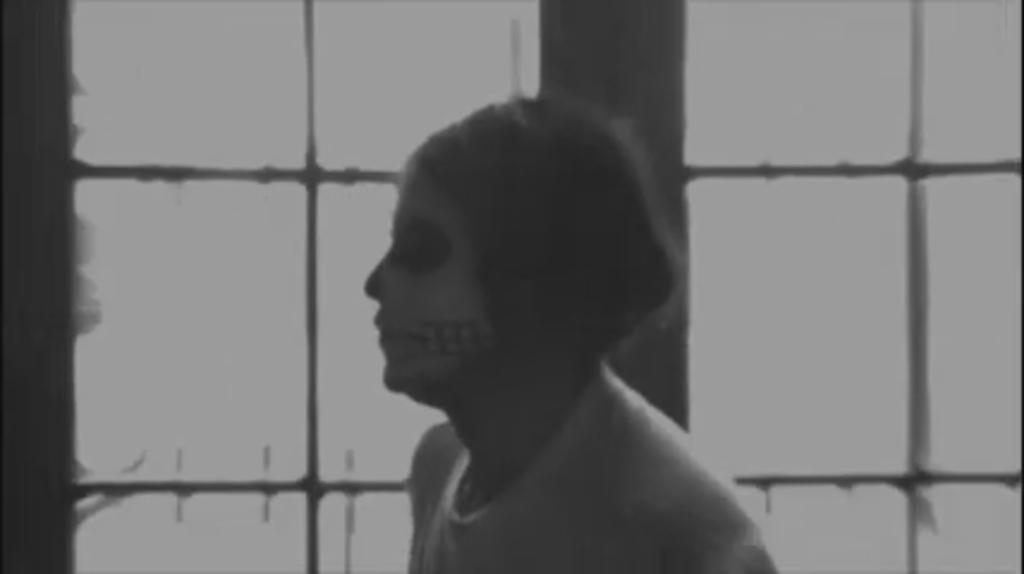Can you describe this image briefly? It is the black and white image in which there is a girl in the middle. In the background there is a window. There is painting on the girls face. 